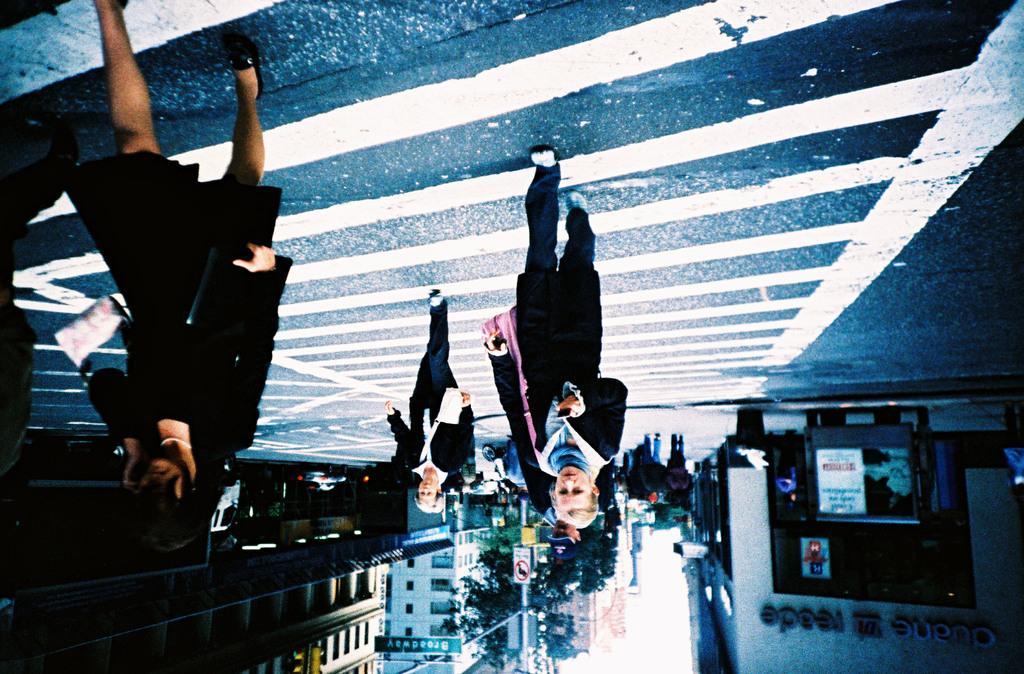Could you give a brief overview of what you see in this image? In this image I can see road and on it I can see white colour lines. I can also see few people are standing and I can see all of them are wearing black dress. In the background I can see few moles, a sign board, few buildings, few signal lights and I can see something is written over there. 